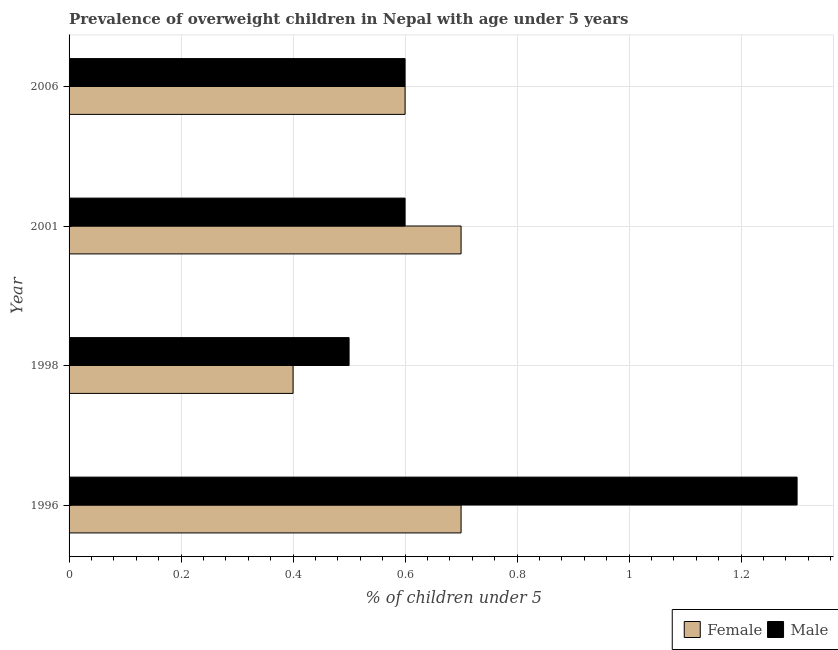How many different coloured bars are there?
Your answer should be compact. 2. How many groups of bars are there?
Ensure brevity in your answer.  4. Are the number of bars on each tick of the Y-axis equal?
Provide a succinct answer. Yes. What is the label of the 1st group of bars from the top?
Provide a short and direct response. 2006. In how many cases, is the number of bars for a given year not equal to the number of legend labels?
Give a very brief answer. 0. What is the percentage of obese male children in 2001?
Your answer should be very brief. 0.6. Across all years, what is the maximum percentage of obese male children?
Make the answer very short. 1.3. Across all years, what is the minimum percentage of obese female children?
Provide a short and direct response. 0.4. In which year was the percentage of obese male children maximum?
Ensure brevity in your answer.  1996. What is the total percentage of obese female children in the graph?
Offer a terse response. 2.4. What is the difference between the percentage of obese female children in 1998 and that in 2001?
Your answer should be very brief. -0.3. What is the difference between the percentage of obese male children in 1998 and the percentage of obese female children in 2001?
Make the answer very short. -0.2. What is the average percentage of obese male children per year?
Provide a succinct answer. 0.75. In the year 1996, what is the difference between the percentage of obese female children and percentage of obese male children?
Your answer should be very brief. -0.6. What is the ratio of the percentage of obese male children in 1998 to that in 2001?
Your answer should be compact. 0.83. Is the percentage of obese female children in 2001 less than that in 2006?
Provide a succinct answer. No. Is the difference between the percentage of obese male children in 1996 and 2001 greater than the difference between the percentage of obese female children in 1996 and 2001?
Provide a succinct answer. Yes. How many bars are there?
Your answer should be very brief. 8. Are all the bars in the graph horizontal?
Make the answer very short. Yes. How many years are there in the graph?
Give a very brief answer. 4. Where does the legend appear in the graph?
Keep it short and to the point. Bottom right. What is the title of the graph?
Your answer should be compact. Prevalence of overweight children in Nepal with age under 5 years. What is the label or title of the X-axis?
Offer a very short reply.  % of children under 5. What is the label or title of the Y-axis?
Provide a succinct answer. Year. What is the  % of children under 5 of Female in 1996?
Provide a succinct answer. 0.7. What is the  % of children under 5 of Male in 1996?
Provide a succinct answer. 1.3. What is the  % of children under 5 of Female in 1998?
Your answer should be very brief. 0.4. What is the  % of children under 5 of Male in 1998?
Keep it short and to the point. 0.5. What is the  % of children under 5 of Female in 2001?
Provide a succinct answer. 0.7. What is the  % of children under 5 in Male in 2001?
Your answer should be compact. 0.6. What is the  % of children under 5 in Female in 2006?
Ensure brevity in your answer.  0.6. What is the  % of children under 5 of Male in 2006?
Keep it short and to the point. 0.6. Across all years, what is the maximum  % of children under 5 of Female?
Your answer should be very brief. 0.7. Across all years, what is the maximum  % of children under 5 in Male?
Ensure brevity in your answer.  1.3. Across all years, what is the minimum  % of children under 5 of Female?
Provide a succinct answer. 0.4. What is the total  % of children under 5 in Female in the graph?
Make the answer very short. 2.4. What is the difference between the  % of children under 5 of Female in 1996 and that in 1998?
Offer a very short reply. 0.3. What is the difference between the  % of children under 5 in Male in 1996 and that in 1998?
Provide a short and direct response. 0.8. What is the difference between the  % of children under 5 of Female in 1996 and that in 2001?
Give a very brief answer. 0. What is the difference between the  % of children under 5 of Male in 1996 and that in 2006?
Offer a terse response. 0.7. What is the difference between the  % of children under 5 of Male in 1998 and that in 2001?
Your answer should be very brief. -0.1. What is the difference between the  % of children under 5 of Female in 1998 and that in 2006?
Ensure brevity in your answer.  -0.2. What is the difference between the  % of children under 5 in Female in 2001 and that in 2006?
Make the answer very short. 0.1. What is the difference between the  % of children under 5 in Female in 1996 and the  % of children under 5 in Male in 2001?
Your answer should be very brief. 0.1. What is the difference between the  % of children under 5 of Female in 2001 and the  % of children under 5 of Male in 2006?
Your answer should be compact. 0.1. What is the average  % of children under 5 of Female per year?
Your answer should be very brief. 0.6. In the year 1996, what is the difference between the  % of children under 5 in Female and  % of children under 5 in Male?
Provide a short and direct response. -0.6. In the year 1998, what is the difference between the  % of children under 5 of Female and  % of children under 5 of Male?
Offer a terse response. -0.1. In the year 2001, what is the difference between the  % of children under 5 of Female and  % of children under 5 of Male?
Offer a very short reply. 0.1. What is the ratio of the  % of children under 5 of Male in 1996 to that in 1998?
Your answer should be compact. 2.6. What is the ratio of the  % of children under 5 of Male in 1996 to that in 2001?
Provide a succinct answer. 2.17. What is the ratio of the  % of children under 5 of Female in 1996 to that in 2006?
Keep it short and to the point. 1.17. What is the ratio of the  % of children under 5 of Male in 1996 to that in 2006?
Make the answer very short. 2.17. What is the ratio of the  % of children under 5 in Male in 1998 to that in 2006?
Your answer should be compact. 0.83. What is the ratio of the  % of children under 5 in Male in 2001 to that in 2006?
Ensure brevity in your answer.  1. What is the difference between the highest and the second highest  % of children under 5 in Female?
Offer a terse response. 0. What is the difference between the highest and the second highest  % of children under 5 in Male?
Provide a short and direct response. 0.7. What is the difference between the highest and the lowest  % of children under 5 of Female?
Ensure brevity in your answer.  0.3. What is the difference between the highest and the lowest  % of children under 5 of Male?
Your answer should be compact. 0.8. 